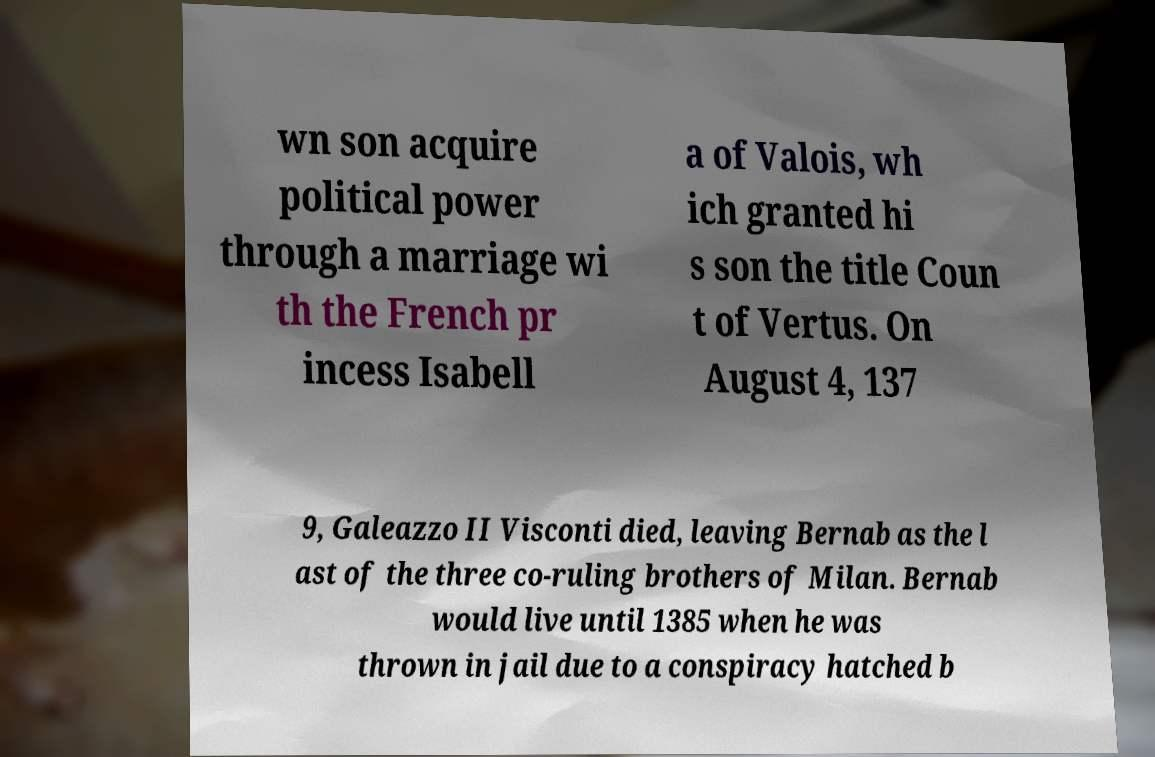Could you assist in decoding the text presented in this image and type it out clearly? wn son acquire political power through a marriage wi th the French pr incess Isabell a of Valois, wh ich granted hi s son the title Coun t of Vertus. On August 4, 137 9, Galeazzo II Visconti died, leaving Bernab as the l ast of the three co-ruling brothers of Milan. Bernab would live until 1385 when he was thrown in jail due to a conspiracy hatched b 